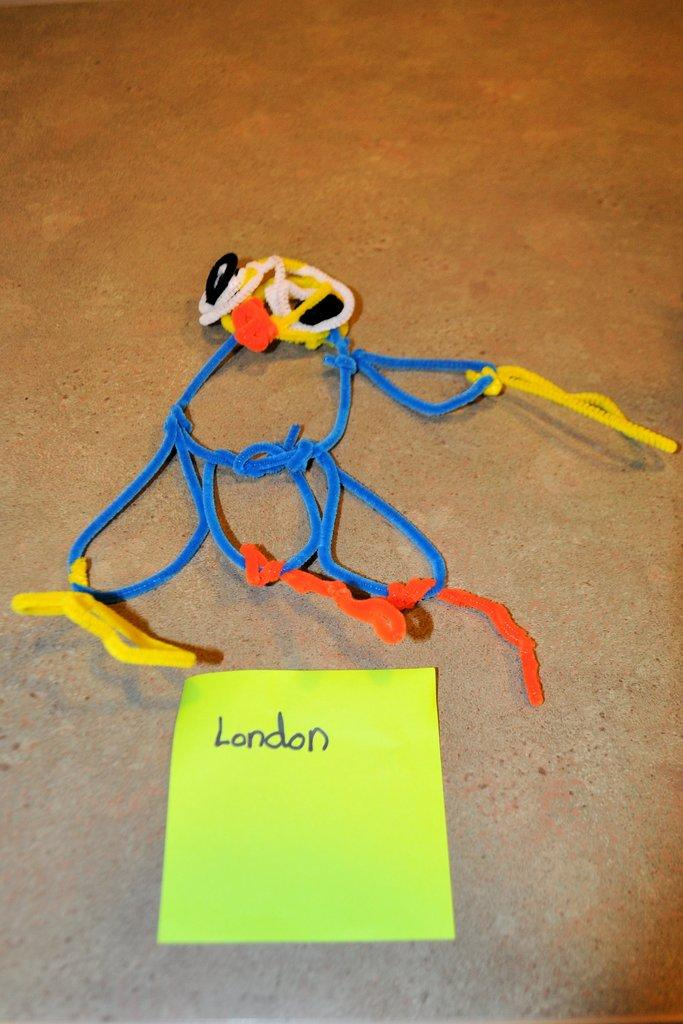What is the main subject in the center of the image? There is a toy in the center of the image. How is the toy made? The toy is made with different color velvet threads. What type of paper is present in the image? There is a light green color paper in the image. What is written on the paper? The word "London" is written on the paper. How does the toy celebrate the holiday in the image? The image does not depict a holiday or any celebratory activities, so it cannot be determined how the toy celebrates a holiday. 